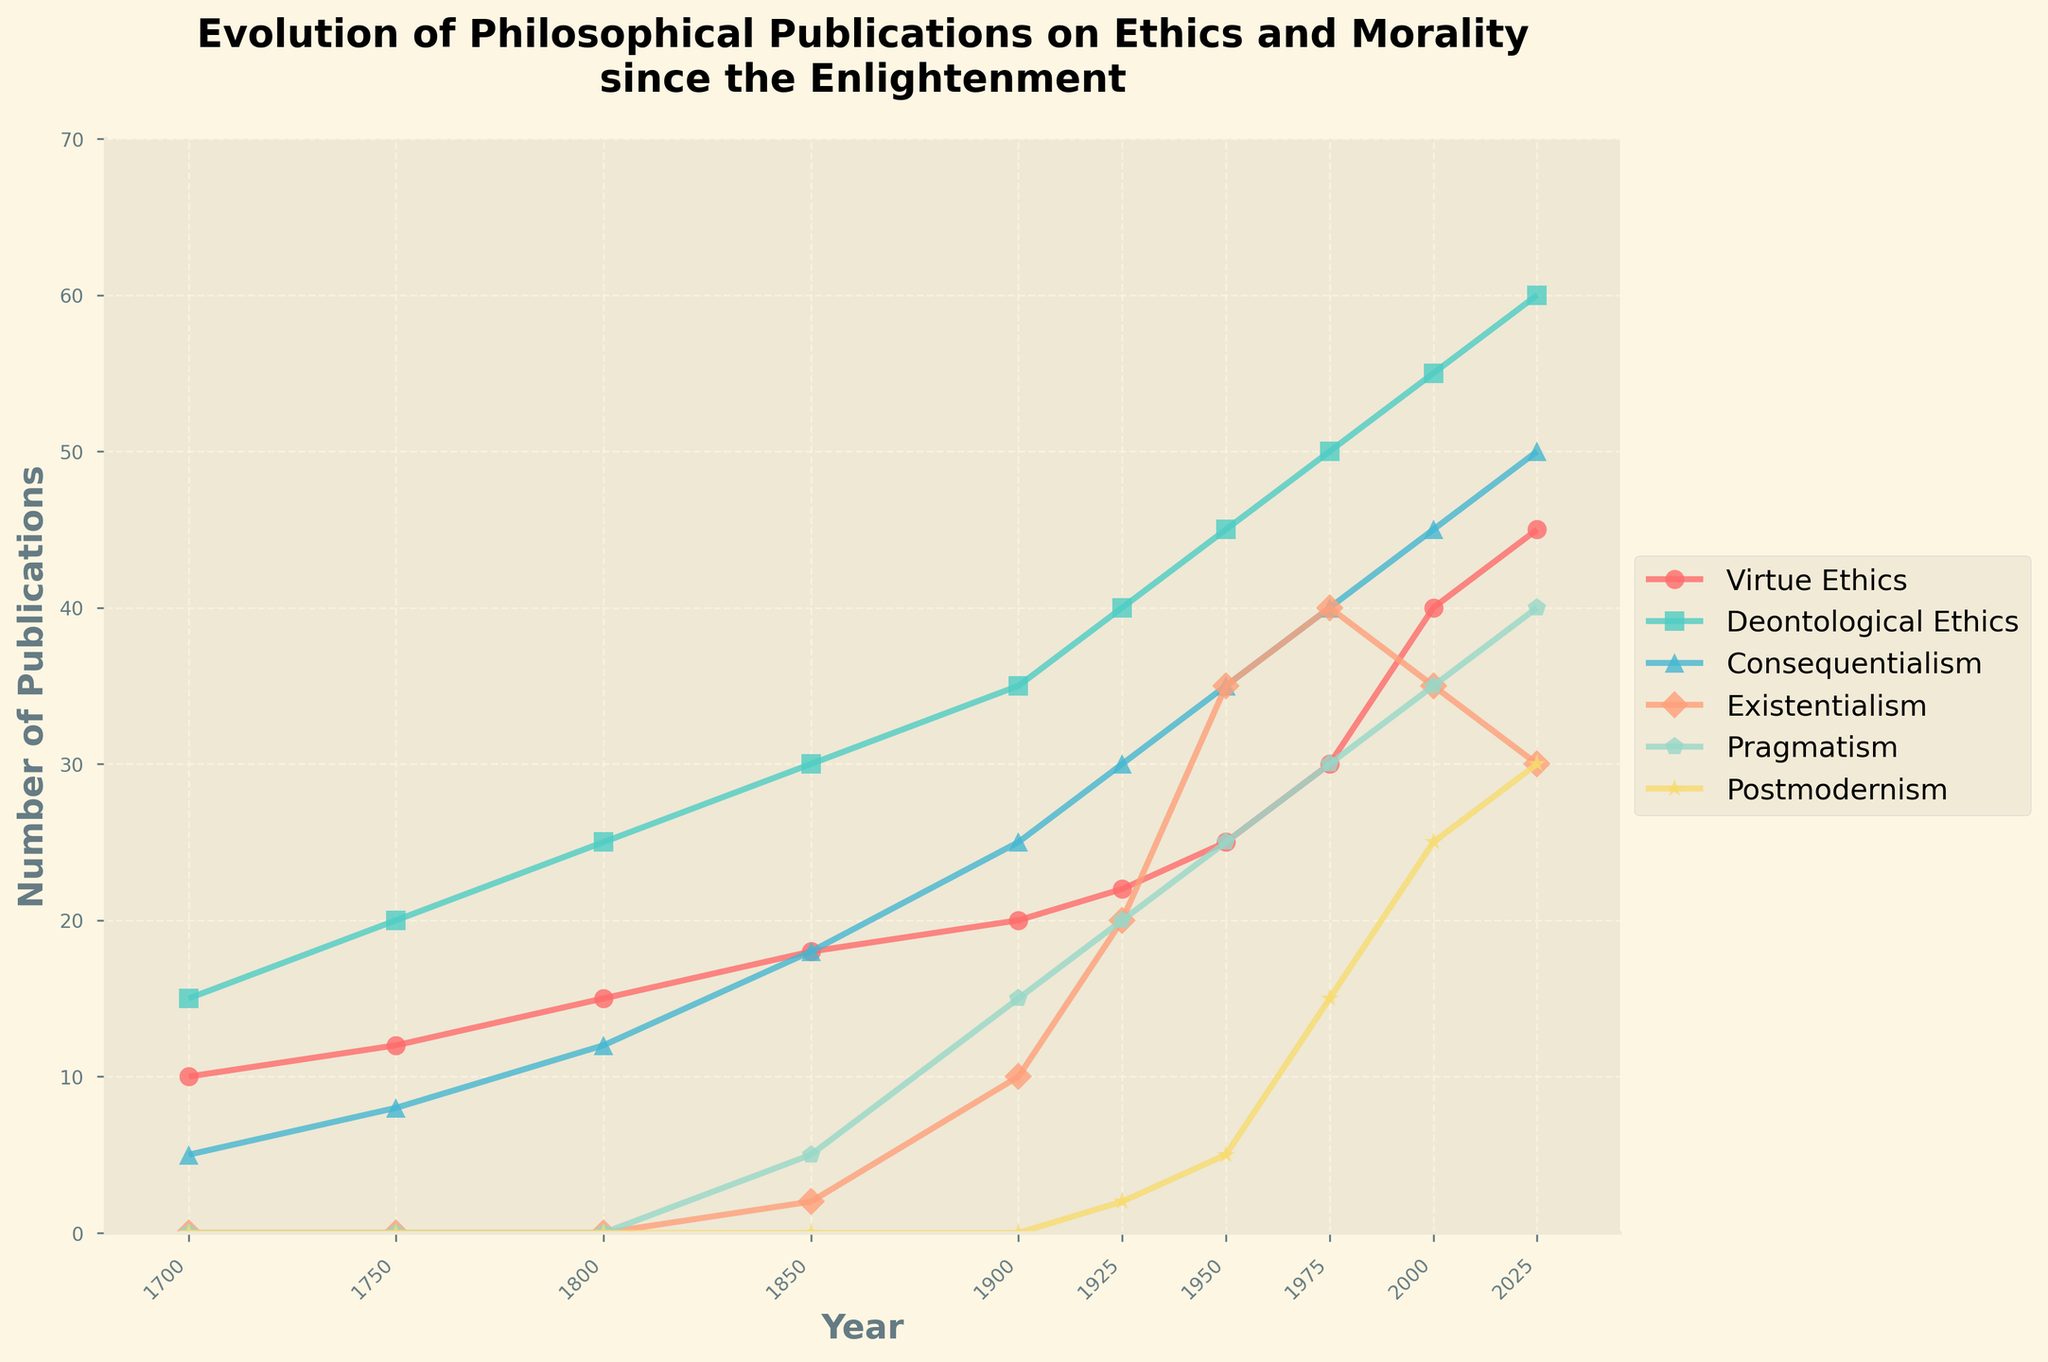What is the trend of Virtue Ethics publications from 1700 to 2025? Virtue Ethics publications show a steady increase over time, starting from 10 in 1700 and rising to 45 in 2025, with no periods of decline.
Answer: Steady increase Which school of thought has the highest number of publications in 2025? By 2025, Deontological Ethics has the highest number of publications with 60 entries, surpassing all other schools of thought shown in the chart.
Answer: Deontological Ethics In which year did Existentialism first start to appear in publications, and what was its initial number of publications? Existentialism first appeared in publications in 1850 with an initial count of 2 publications.
Answer: 1850, 2 publications Between 1900 and 2000, which school of thought saw the largest increase in the number of publications? From 1900 to 2000, Deontological Ethics experienced the largest increase in the number of publications, growing from 35 to 55, an increase of 20 publications.
Answer: Deontological Ethics Compare the number of publications for Postmodernism in 1925 and 2025. How much did they increase? Postmodernism had 2 publications in 1925 and increased to 30 publications by 2025. The increase is 28 publications.
Answer: 28 publications What is the average number of publications for Consequentialism from 1700 to 2025? The sum of publications for Consequentialism from 1700 to 2025 is 5 + 8 + 12 + 18 + 25 + 30 + 35 + 40 + 45 + 50 = 268. There are 10 data points, so the average is 268 / 10 = 26.8.
Answer: 26.8 By how many publications did Pragmatism increase from 1850 to 1950? In 1850, Pragmatism had 5 publications, and it rose to 25 publications by 1950, showing an increase of 20 publications.
Answer: 20 publications Which schools of thought had more than 40 publications by the year 2000? By the year 2000, three schools of thought had more than 40 publications: Virtue Ethics (40), Deontological Ethics (55), and Consequentialism (45).
Answer: Virtue Ethics, Deontological Ethics, Consequentialism 